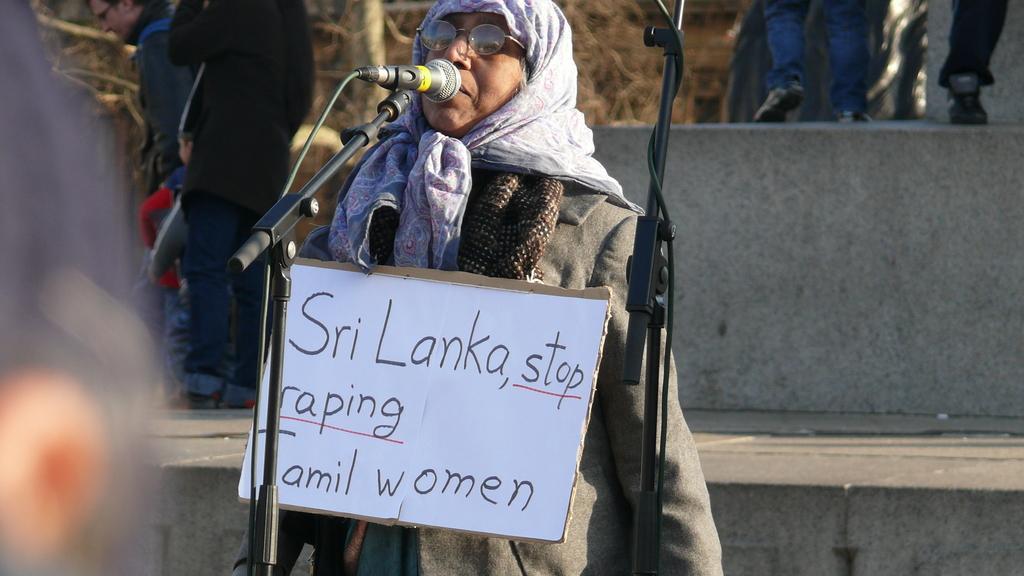Could you give a brief overview of what you see in this image? In the center of the picture there is a woman holding a placard and speaking into mic. In the foreground there is a microphone. In the background there are people and trees. It is sunny. 